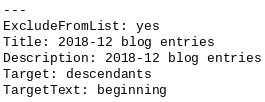<code> <loc_0><loc_0><loc_500><loc_500><_YAML_>---
ExcludeFromList: yes
Title: 2018-12 blog entries
Description: 2018-12 blog entries
Target: descendants
TargetText: beginning</code> 